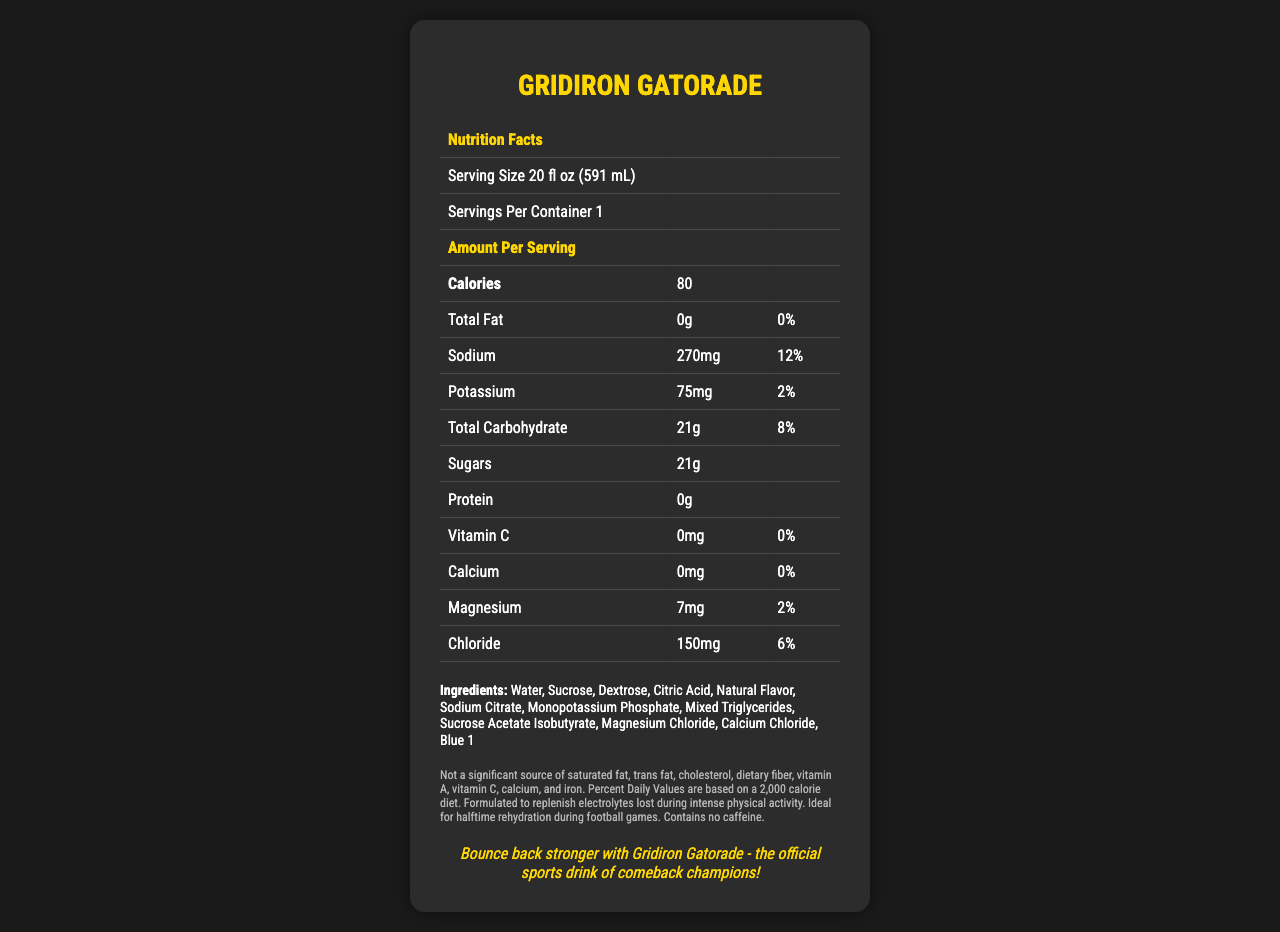what is the serving size for Gridiron Gatorade? The serving size is mentioned at the top of the document in the nutrition facts table.
Answer: 20 fl oz (591 mL) how many calories are in one serving of Gridiron Gatorade? The amount of calories per serving is listed directly after the serving size information.
Answer: 80 calories how much total fat does Gridiron Gatorade contain? The total fat content is specified as 0g in the nutrition facts table.
Answer: 0g what percentage of the daily value of sodium is in one serving? In the nutrition facts section, the daily value of sodium is listed as 12%.
Answer: 12% how much potassium is there in Gridiron Gatorade per serving? The amount of potassium per serving is given as 75mg in the nutrition facts table.
Answer: 75mg which ingredient is listed last in the ingredients list? The ingredients are listed in order, and Blue 1 is the last ingredient mentioned.
Answer: Blue 1 how many grams of carbohydrates does Gridiron Gatorade contain in one serving? The total carbohydrate content per serving is listed as 21g in the nutrition facts table.
Answer: 21g which of the following minerals are included in Gridiron Gatorade? A. Iron B. Magnesium C. Zinc D. Phosphorus Magnesium is listed in the nutrition facts table, whereas iron, zinc, and phosphorus are not mentioned.
Answer: B. Magnesium how many grams of protein are in Gridiron Gatorade? The document clearly states that there are 0g of protein per serving.
Answer: 0g is Gridiron Gatorade a source of caffeine? The additional information mentions that Gridiron Gatorade contains no caffeine.
Answer: No how much chloride does Gridiron Gatorade contain? A. 75mg B. 150mg C. 200mg D. 270mg The nutrition facts table lists the chloride content as 150mg.
Answer: B. 150mg is vitamin C a significant source in Gridiron Gatorade? The document states that it is not a significant source of vitamin C, with 0mg and 0% daily value.
Answer: No which tagline is featured in the document? The tagline is mentioned at the bottom of the document, promoting the product as ideal for comeback champions.
Answer: Bounce back stronger with Gridiron Gatorade - the official sports drink of comeback champions! summarize the main purpose of Gridiron Gatorade according to the document. The document describes the drink's nutritional content, emphasizing its role in replenishing electrolytes and its suitability for sports.
Answer: Gridiron Gatorade is a sports drink formulated to replenish electrolytes and provide rehydration during intense physical activity, ideal for athletes, especially football players during halftime. how much dietary fiber does Gridiron Gatorade contain? The document does not provide information on dietary fiber content in Gridiron Gatorade.
Answer: I don't know 